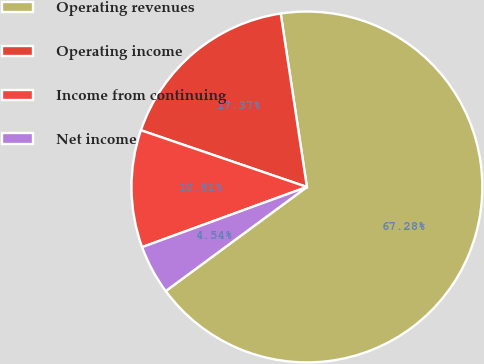<chart> <loc_0><loc_0><loc_500><loc_500><pie_chart><fcel>Operating revenues<fcel>Operating income<fcel>Income from continuing<fcel>Net income<nl><fcel>67.27%<fcel>17.37%<fcel>10.81%<fcel>4.54%<nl></chart> 